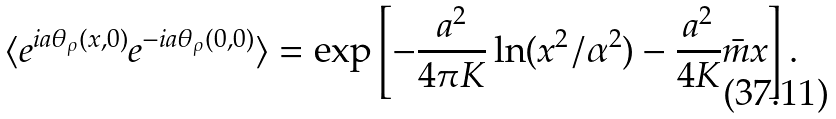Convert formula to latex. <formula><loc_0><loc_0><loc_500><loc_500>\langle e ^ { i a \theta _ { \rho } ( x , 0 ) } e ^ { - i a \theta _ { \rho } ( 0 , 0 ) } \rangle = \exp \left [ - \frac { a ^ { 2 } } { 4 \pi K } \ln ( x ^ { 2 } / \alpha ^ { 2 } ) - \frac { a ^ { 2 } } { 4 K } \bar { m } x \right ] .</formula> 